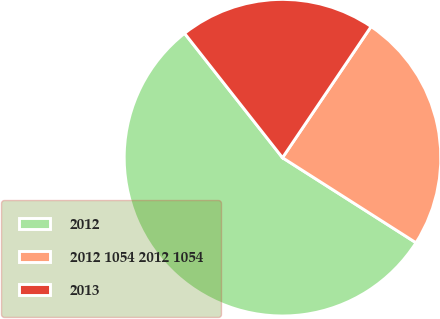<chart> <loc_0><loc_0><loc_500><loc_500><pie_chart><fcel>2012<fcel>2012 1054 2012 1054<fcel>2013<nl><fcel>55.35%<fcel>24.57%<fcel>20.07%<nl></chart> 